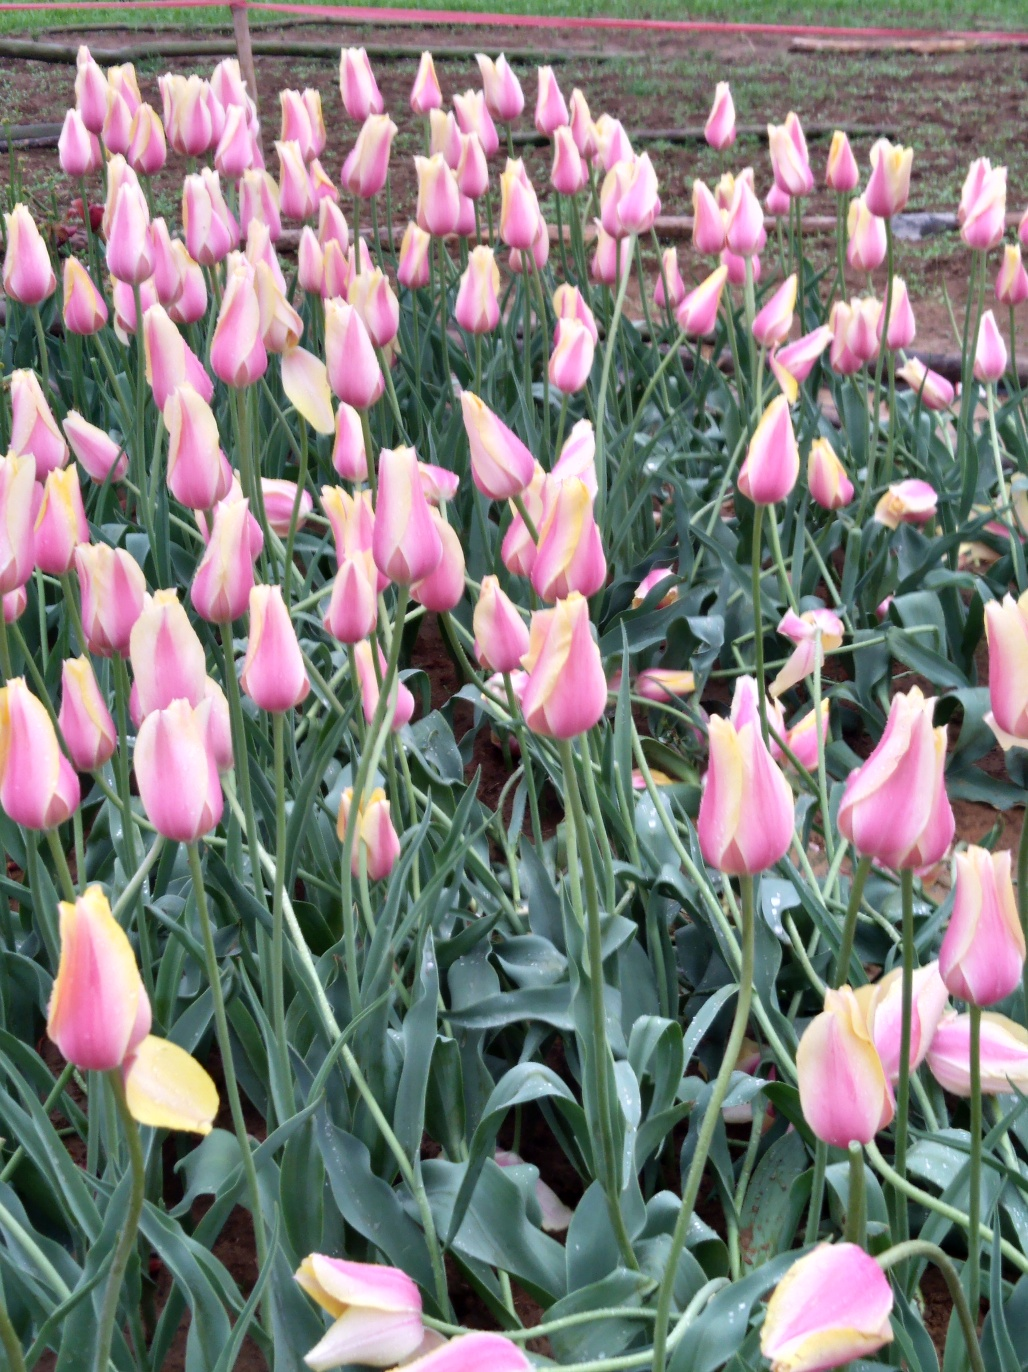What time of year is it likely given the flowers' appearance? Given that the tulips are in bloom, it's likely springtime, which is the typical blooming season for tulips. They generally flower in the spring for a period of 3-7 days, depending on the weather conditions. What can you tell me about the way these tulips are planted? These tulips are planted in rows, a common practice for commercial flower cultivation which facilitates maintenance and harvesting. The tulips are spaced to allow each plant enough room to grow while maximizing the use of space. 